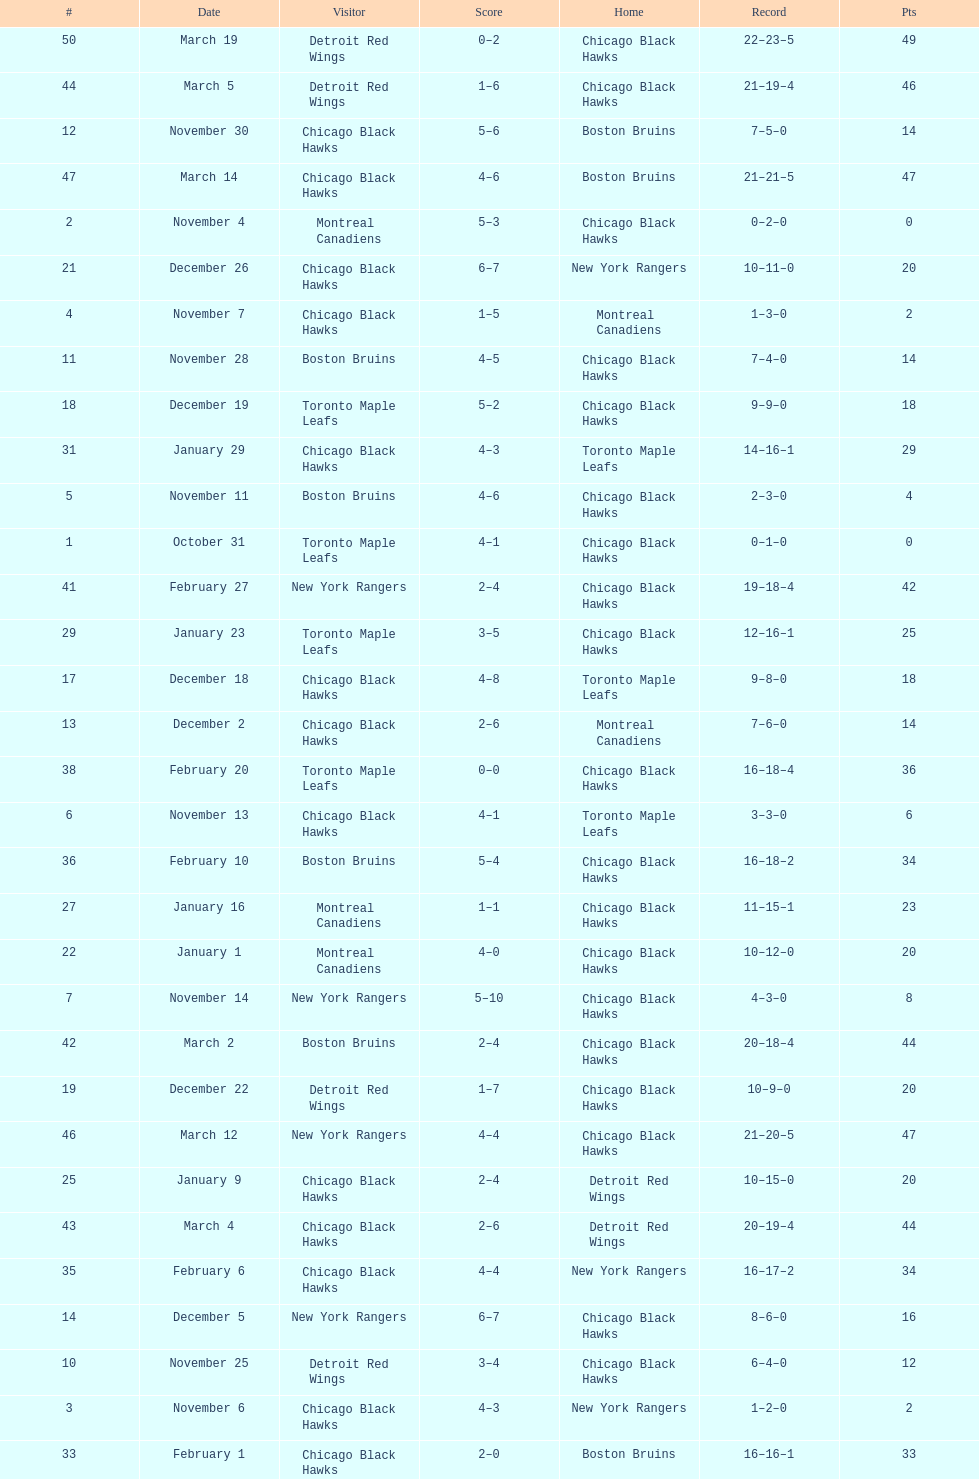How many games total were played? 50. 